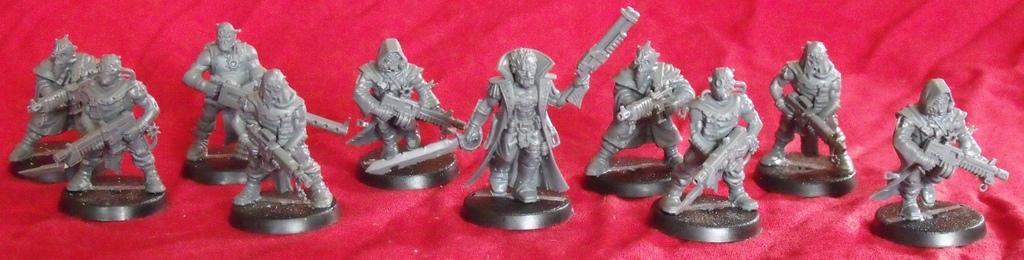In one or two sentences, can you explain what this image depicts? In the foreground of this image, there are toy statues on the red surface. 